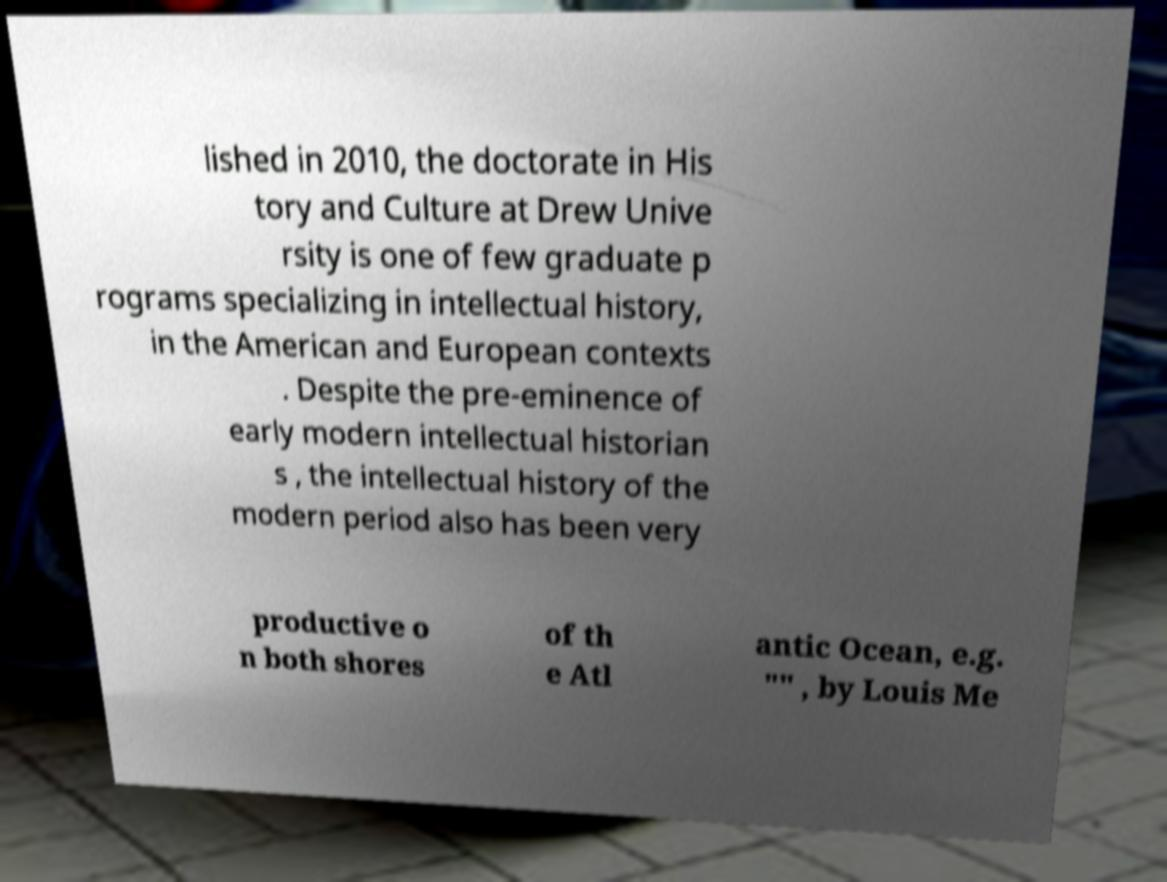For documentation purposes, I need the text within this image transcribed. Could you provide that? lished in 2010, the doctorate in His tory and Culture at Drew Unive rsity is one of few graduate p rograms specializing in intellectual history, in the American and European contexts . Despite the pre-eminence of early modern intellectual historian s , the intellectual history of the modern period also has been very productive o n both shores of th e Atl antic Ocean, e.g. "" , by Louis Me 